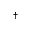Convert formula to latex. <formula><loc_0><loc_0><loc_500><loc_500>^ { \dagger }</formula> 